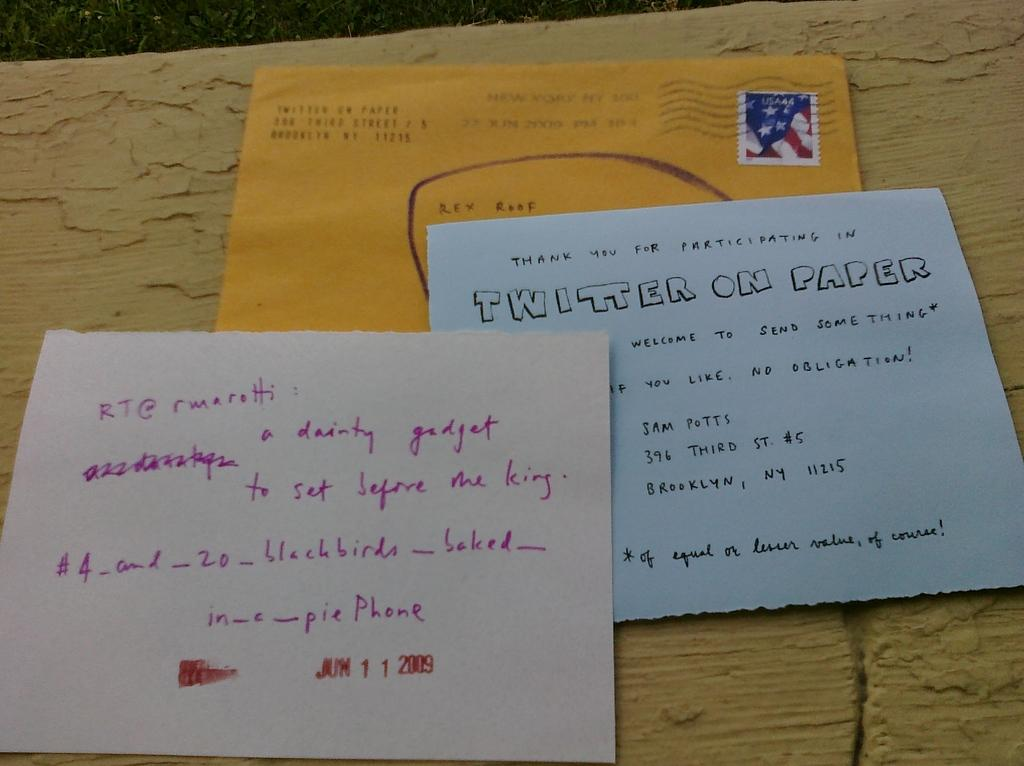<image>
Write a terse but informative summary of the picture. A Twitter on paper item on a desk 